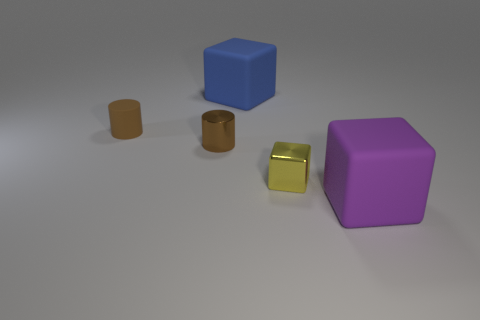Subtract all matte cubes. How many cubes are left? 1 Add 5 cyan matte objects. How many objects exist? 10 Subtract all yellow blocks. How many blocks are left? 2 Subtract all cylinders. How many objects are left? 3 Add 2 blue objects. How many blue objects exist? 3 Subtract 0 green balls. How many objects are left? 5 Subtract 1 blocks. How many blocks are left? 2 Subtract all gray cubes. Subtract all gray cylinders. How many cubes are left? 3 Subtract all brown shiny cylinders. Subtract all blocks. How many objects are left? 1 Add 5 tiny brown matte objects. How many tiny brown matte objects are left? 6 